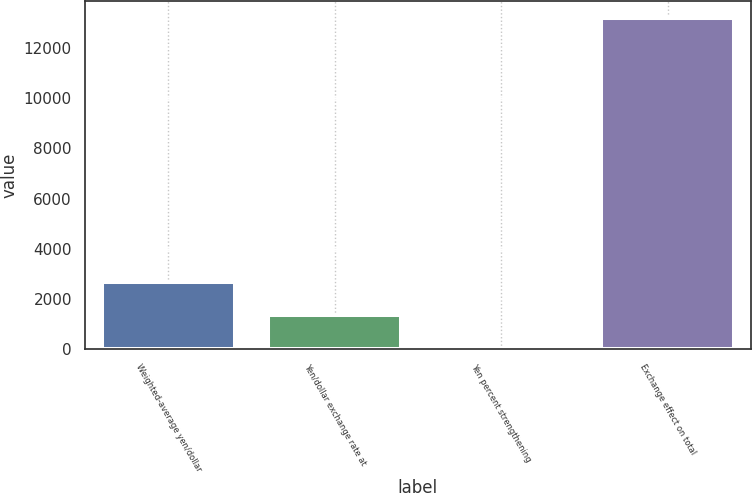Convert chart to OTSL. <chart><loc_0><loc_0><loc_500><loc_500><bar_chart><fcel>Weighted-average yen/dollar<fcel>Yen/dollar exchange rate at<fcel>Yen percent strengthening<fcel>Exchange effect on total<nl><fcel>2682.72<fcel>1354.06<fcel>25.4<fcel>13180<nl></chart> 